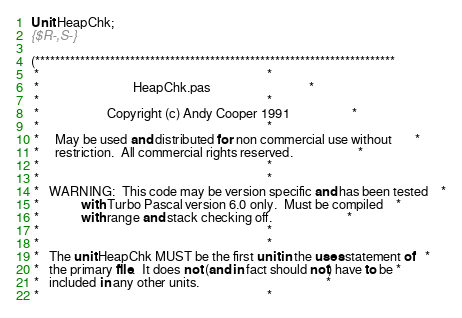<code> <loc_0><loc_0><loc_500><loc_500><_Pascal_>
Unit HeapChk;
{$R-,S-}

(************************************************************************
 *                                                                      *
 *                             HeapChk.pas                              *
 *                                                                      *
 *                     Copyright (c) Andy Cooper 1991                   *
 *                                                                      *
 *     May be used and distributed for non commercial use without       *
 *     restriction.  All commercial rights reserved.                    *
 *                                                                      *
 *                                                                      *
 *   WARNING:  This code may be version specific and has been tested    *
 *             with Turbo Pascal version 6.0 only.  Must be compiled    *
 *             with range and stack checking off.                       *
 *                                                                      *
 *                                                                      *
 *   The unit HeapChk MUST be the first unit in the uses statement of   *
 *   the primary file.  It does not (and in fact should not) have to be *
 *   included in any other units.                                       *
 *                                                                      *</code> 